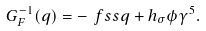<formula> <loc_0><loc_0><loc_500><loc_500>G ^ { - 1 } _ { F } ( q ) = - \ f s s { q } + h _ { \sigma } \phi \gamma ^ { 5 } .</formula> 